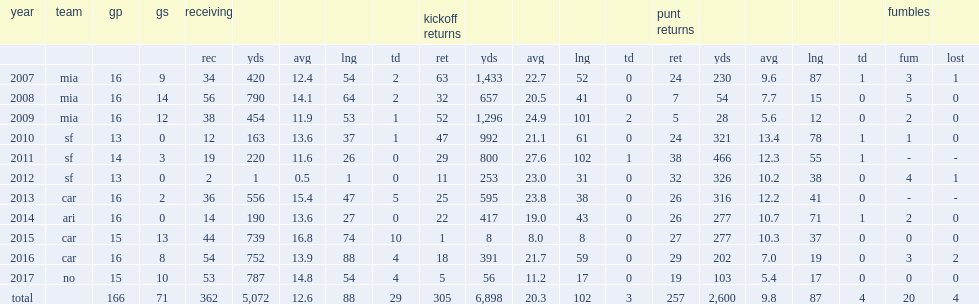How many receptions did ginn finish the 2010 season with? 12.0. 